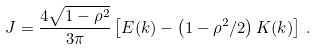<formula> <loc_0><loc_0><loc_500><loc_500>J = \frac { 4 \sqrt { 1 - \rho ^ { 2 } } } { 3 \pi } \left [ E ( k ) - \left ( 1 - \rho ^ { 2 } / 2 \right ) K ( k ) \right ] \, .</formula> 